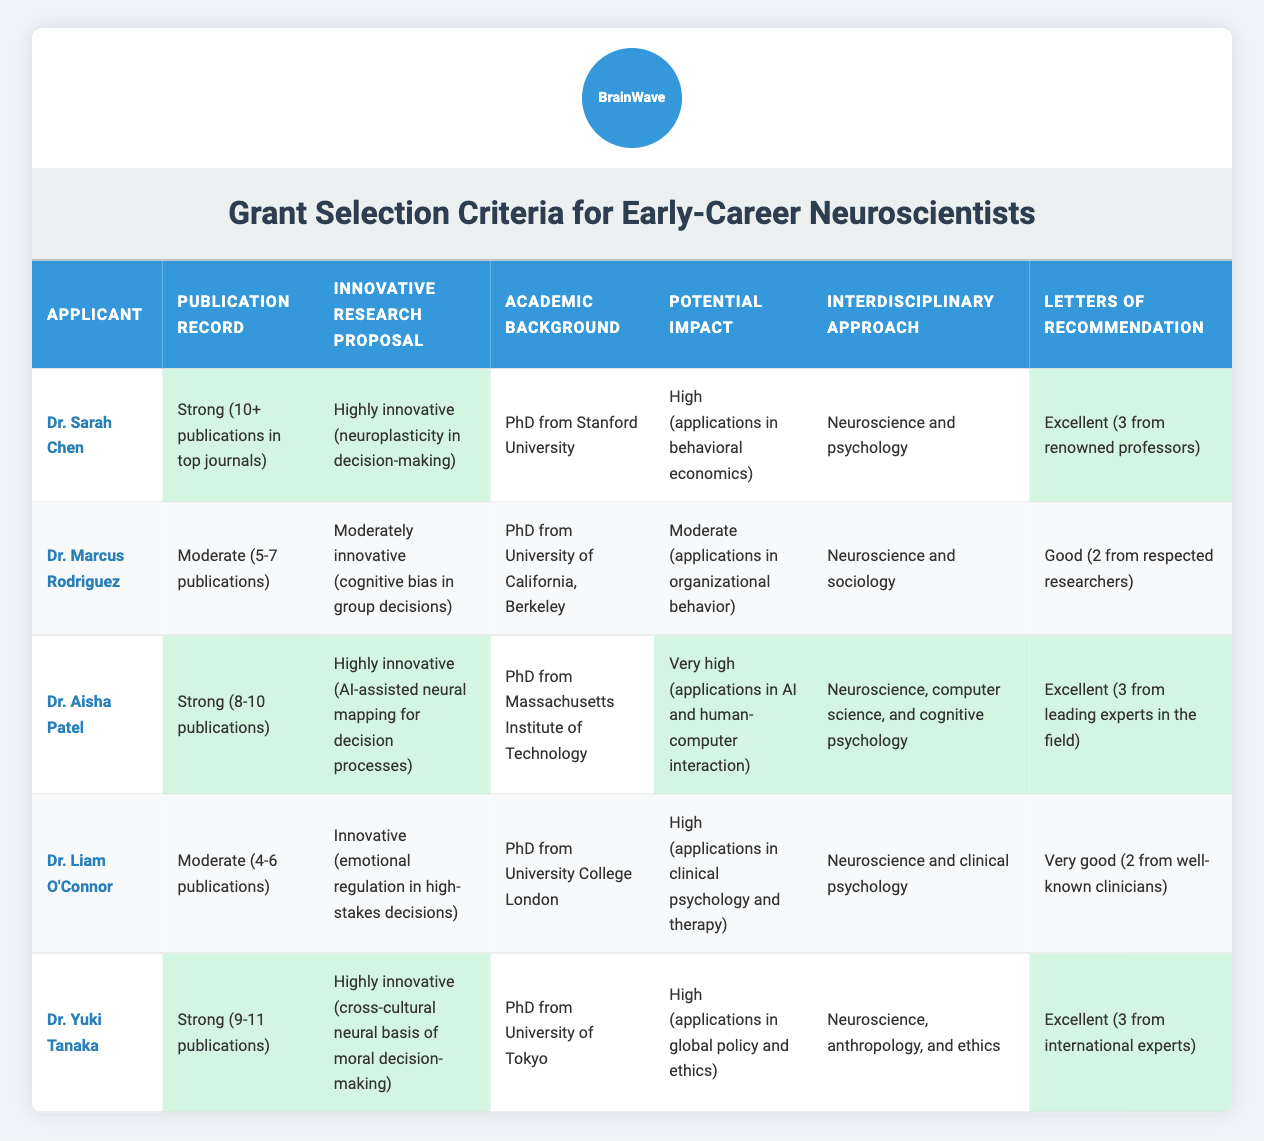What is the academic background of Dr. Aisha Patel? Dr. Aisha Patel's academic background is listed as "PhD from Massachusetts Institute of Technology" in the corresponding cell of the table.
Answer: PhD from Massachusetts Institute of Technology Which applicant has the most publications? By comparing the publication records, Dr. Yuki Tanaka has a strong record of "9-11 publications," which is higher than the others, confirming she has the most publications.
Answer: Dr. Yuki Tanaka Did Dr. Marcus Rodriguez receive excellent letters of recommendation? The table indicates that Dr. Marcus Rodriguez has "Good (2 from respected researchers)" for letters of recommendation, which does not qualify as excellent.
Answer: No What is the potential impact rating of Dr. Aisha Patel's research proposal? The table states that Dr. Aisha Patel has a potential impact rating of "Very high (applications in AI and human-computer interaction)," which clearly specifies her research's potential impact level.
Answer: Very high How many applicants had a strong publication record? From the table, the applicants with a strong publication record are Dr. Sarah Chen, Dr. Aisha Patel, and Dr. Yuki Tanaka, which sums up to three applicants.
Answer: 3 Which applicant has an interdisciplinary approach involving anthropology? The table shows that Dr. Yuki Tanaka has an interdisciplinary approach of "Neuroscience, anthropology, and ethics," indicating she is the applicant that includes anthropology in her approach.
Answer: Dr. Yuki Tanaka What is the average number of publications among all applicants? The publication records indicate the ranges: Dr. Sarah Chen (10), Dr. Marcus Rodriguez (6), Dr. Aisha Patel (9), Dr. Liam O'Connor (5), and Dr. Yuki Tanaka (10). Adding these values gives a total of 40; divided by the number of applicants (5) results in an average of 8 publications.
Answer: 8 Is it true that all applicants received at least two letters of recommendation? Evaluating the letters of recommendation indicates that every applicant has received at least two: Dr. Sarah Chen (3), Dr. Marcus Rodriguez (2), Dr. Aisha Patel (3), Dr. Liam O'Connor (2), and Dr. Yuki Tanaka (3), confirming it to be true.
Answer: Yes What is the innovative research proposal of Dr. Liam O'Connor? The table states Dr. Liam O'Connor's innovative research proposal as "Innovative (emotional regulation in high-stakes decisions)," providing a clear description of his work.
Answer: Innovative (emotional regulation in high-stakes decisions) 